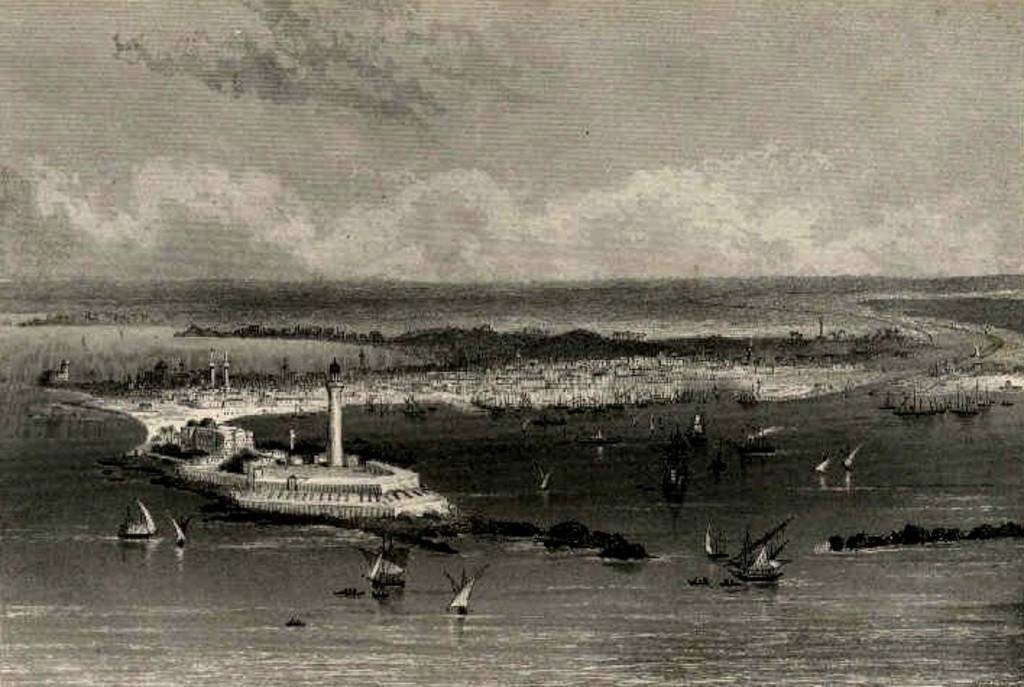What is the color scheme of the image? The image is black and white. How would you describe the quality of the image? The image is blurry. What type of vehicles can be seen in the image? There are boats in the image. What natural element is visible in the image? There is water visible in the image. What type of structure is present in the image? There is a tower in the image. What is visible in the background of the image? The sky is visible in the image. Can you see any spots on the birds in the image? There are no birds present in the image, so it is not possible to see any spots on them. 